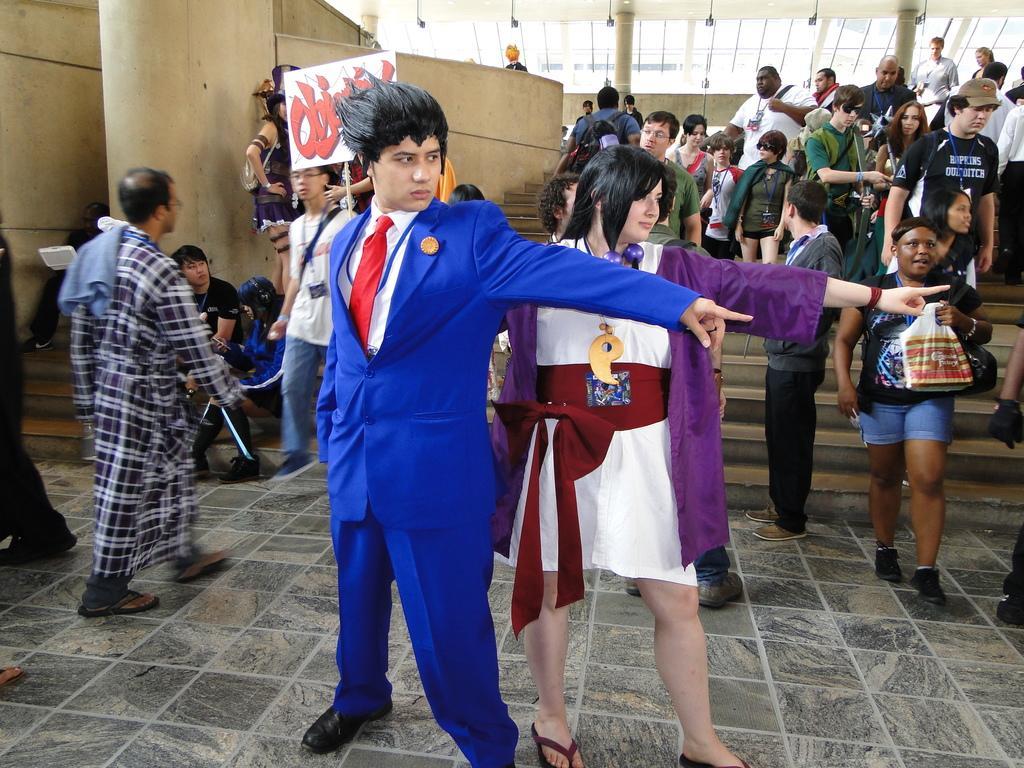Could you give a brief overview of what you see in this image? In this image we can see some people standing on the floor. In that a person is holding a clover and the other is holding a board with some text on it. On the left side we can see some people sitting. In that a person is holding an object. On the backside we can see a group of people standing on the staircase. We can also see a wall, pillars and a roof with some lights. 